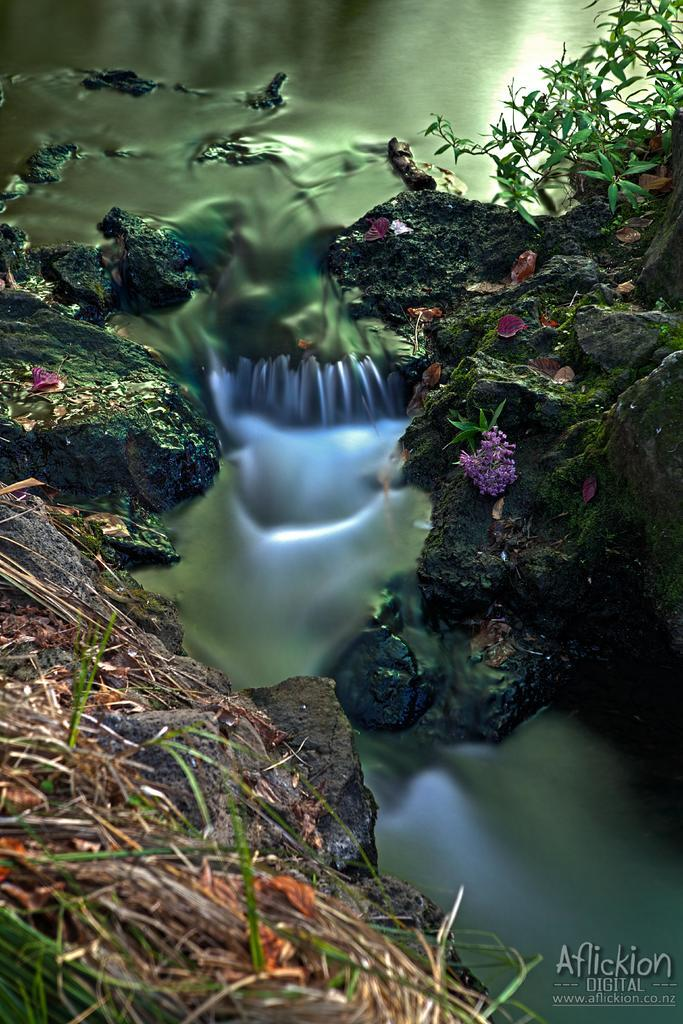What is the main element in the image? There is water in the image. What is the water situated between? The water is between rocks. Where is the plant located in the image? There is a plant in the top right of the image. What is present in the bottom right of the image? There is text in the bottom right of the image. What type of pet is being discussed in the image? There is no discussion or pet present in the image. 